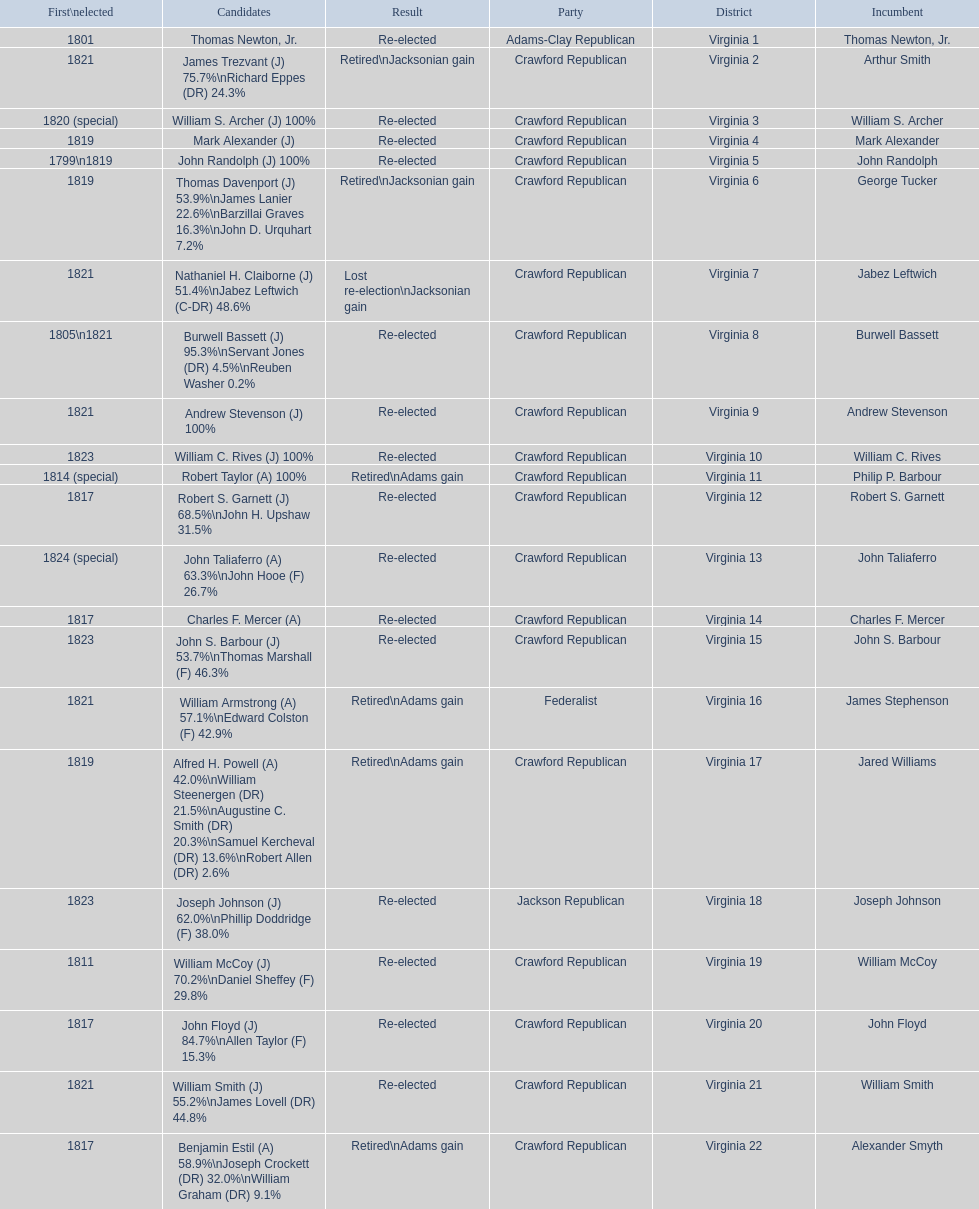What is the last party on this chart? Crawford Republican. 